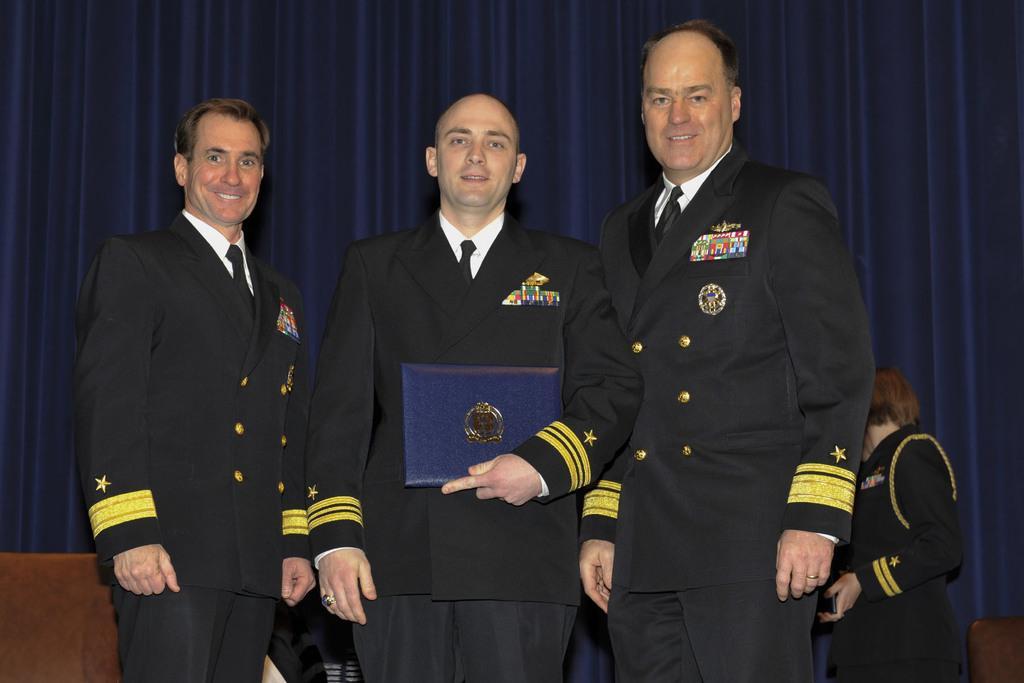Could you give a brief overview of what you see in this image? In this picture we can see some people are standing and smiling and wearing coats and a man is holding an object. In the background of the image we can see the curtain. At the bottom of the image we can see the chairs. 